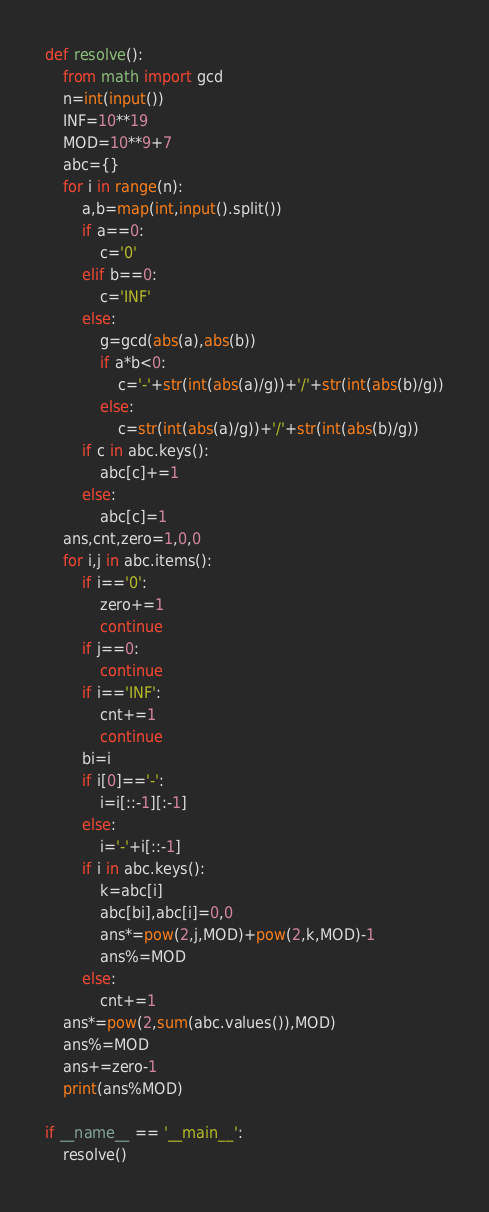<code> <loc_0><loc_0><loc_500><loc_500><_Python_>def resolve():
    from math import gcd
    n=int(input())
    INF=10**19
    MOD=10**9+7
    abc={}
    for i in range(n):
        a,b=map(int,input().split())
        if a==0:
            c='0'
        elif b==0:
            c='INF'
        else:
            g=gcd(abs(a),abs(b))
            if a*b<0:
                c='-'+str(int(abs(a)/g))+'/'+str(int(abs(b)/g))
            else:
                c=str(int(abs(a)/g))+'/'+str(int(abs(b)/g))
        if c in abc.keys():
            abc[c]+=1
        else:
            abc[c]=1
    ans,cnt,zero=1,0,0
    for i,j in abc.items():
        if i=='0':
            zero+=1
            continue
        if j==0:
            continue
        if i=='INF':
            cnt+=1
            continue
        bi=i
        if i[0]=='-':
            i=i[::-1][:-1]
        else:
            i='-'+i[::-1]
        if i in abc.keys():
            k=abc[i]
            abc[bi],abc[i]=0,0
            ans*=pow(2,j,MOD)+pow(2,k,MOD)-1
            ans%=MOD
        else:
            cnt+=1
    ans*=pow(2,sum(abc.values()),MOD)
    ans%=MOD
    ans+=zero-1
    print(ans%MOD)

if __name__ == '__main__':
    resolve()</code> 